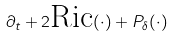<formula> <loc_0><loc_0><loc_500><loc_500>\partial _ { t } + 2 \text {Ric} ( \cdot ) + P _ { \delta } ( \cdot )</formula> 